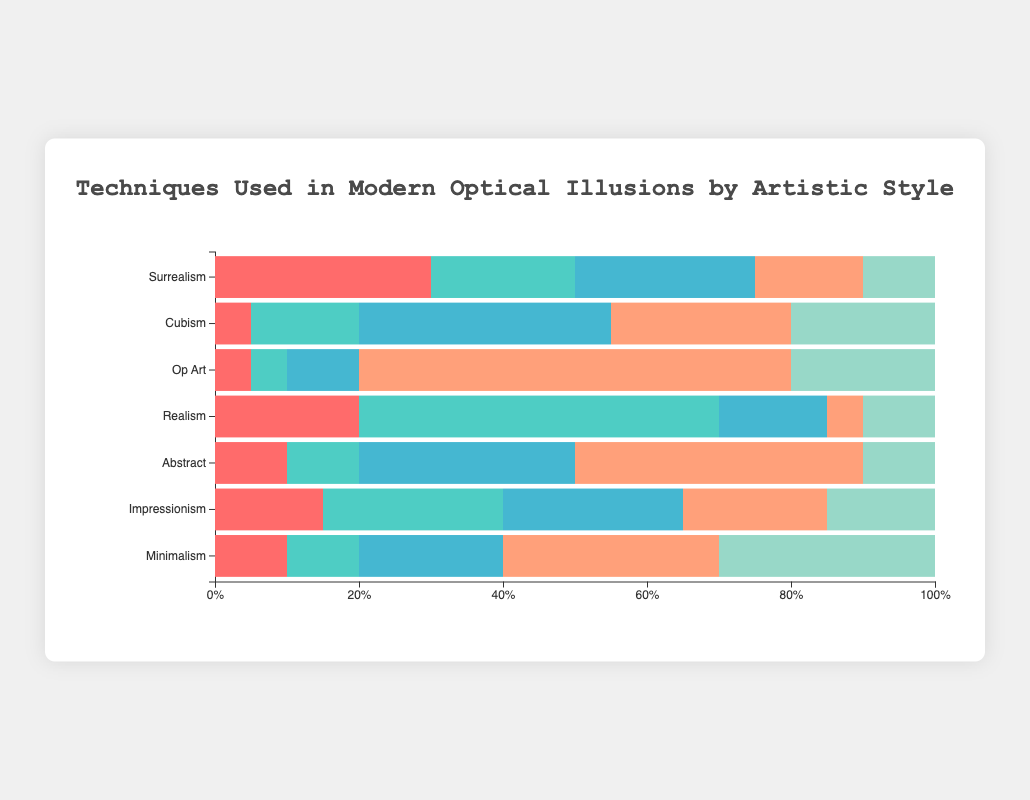Which artistic style uses Trompe l'œil the most? Look at the bar sections colored for Trompe l'œil for each artistic style. The longest bar section for Trompe l'œil corresponds to Realism.
Answer: Realism In terms of Forced Perspective, how does Surrealism compare to Cubism? Compare the lengths of the Forced Perspective sections for Surrealism (30) and Cubism (5). Surrealism has a longer section than Cubism for Forced Perspective.
Answer: Surrealism uses more Forced Perspective Which artistic styles have equal percentages of Hybrid Images? Observe the lengths of the bar sections for Hybrid Images (colored section related to Hybrid Images) for all artistic styles. Surrealism, Realism, Abstract, and Minimalism each have 10%.
Answer: Surrealism, Realism, and Abstract How much higher is the usage of Ambiguous Images in Minimalism compared to Surrealism? Find the Ambiguous Images usage in Minimalism (20) and Surrealism (25). Subtract the lower value from the higher value: 25 - 20.
Answer: 5% higher in Surrealism Which artistic style has the least usage of Op Art Patterns? Look for the smallest section colored for Op Art Patterns among all artistic styles. Realism has the smallest Op Art Patterns section at 5%.
Answer: Realism Between Impressionism and Op Art, which uses Forced Perspective more and by how much? Check the Forced Perspective sections for Impressionism (15) and Op Art (5). Subtract the smaller value from the larger value: 15 - 5.
Answer: Impressionism uses 10% more Forced Perspective What is the combined percentage of Op Art Patterns and Trompe l'œil in Abstract? Add the percentages of Op Art Patterns (40) and Trompe l'œil (10) for Abstract. 40 + 10.
Answer: 50% Rank the artistic styles by their usage of Ambiguous Images from highest to lowest. Compare the lengths of the Ambiguous Images sections for all artistic styles: Cubism (35), Abstract (30), Impressionism (25), Surrealism (25), Minimalism (20), Realism (15), Op Art (10).
Answer: Cubism, Abstract, Impressionism, Surrealism, Minimalism, Realism, Op Art For which artistic styles does Hybrid Images constitute one of the top two techniques used? Check the bar sections to see where Hybrid Images (colored appropriately) is one of the top two largest sections. Minimalism has Hybrid Images as the largest section, and Cubism has it as the second largest.
Answer: Minimalism and Cubism 